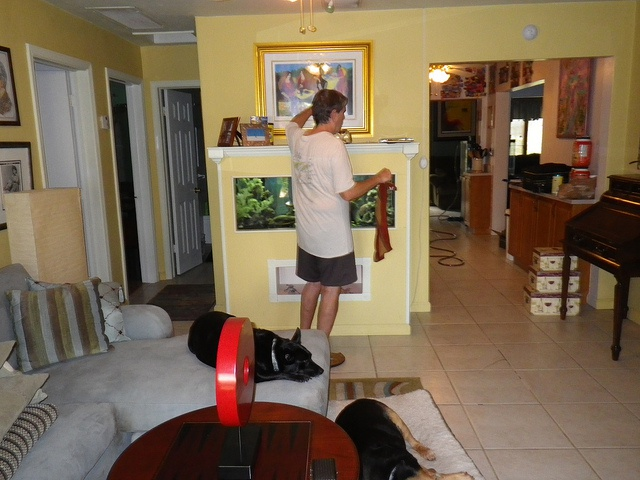Describe the objects in this image and their specific colors. I can see couch in olive, gray, and black tones, dining table in olive, black, maroon, gray, and darkgray tones, people in olive, darkgray, black, and brown tones, dog in olive, black, gray, darkgray, and tan tones, and dog in olive, black, gray, maroon, and darkgray tones in this image. 